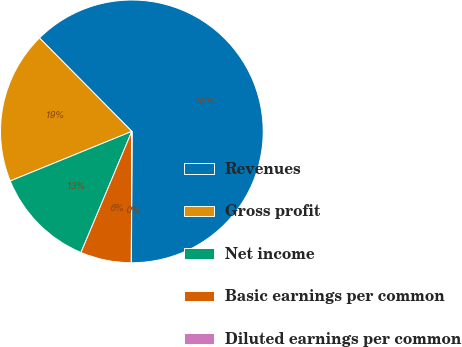<chart> <loc_0><loc_0><loc_500><loc_500><pie_chart><fcel>Revenues<fcel>Gross profit<fcel>Net income<fcel>Basic earnings per common<fcel>Diluted earnings per common<nl><fcel>62.46%<fcel>18.75%<fcel>12.51%<fcel>6.26%<fcel>0.02%<nl></chart> 